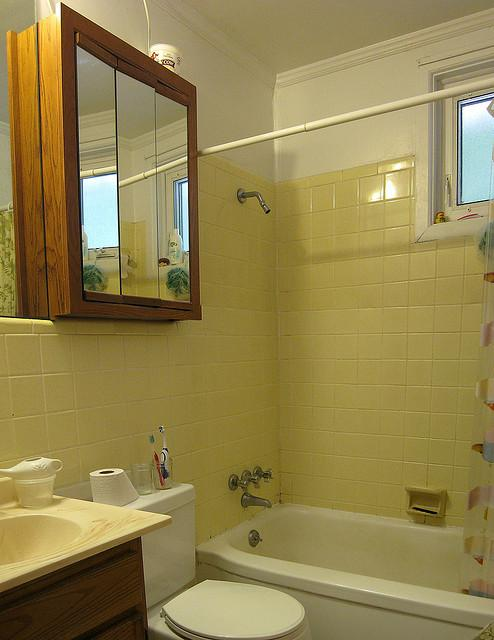What happens behind the curtain?

Choices:
A) eating
B) sleeping
C) movie time
D) cleaning cleaning 